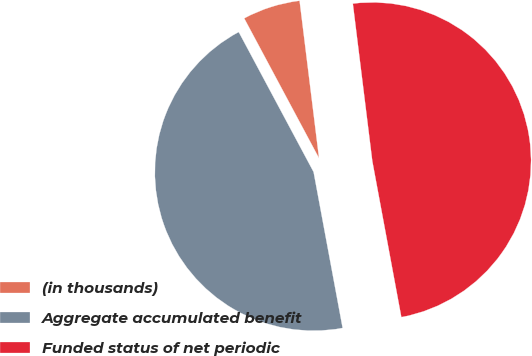<chart> <loc_0><loc_0><loc_500><loc_500><pie_chart><fcel>(in thousands)<fcel>Aggregate accumulated benefit<fcel>Funded status of net periodic<nl><fcel>5.86%<fcel>45.11%<fcel>49.03%<nl></chart> 